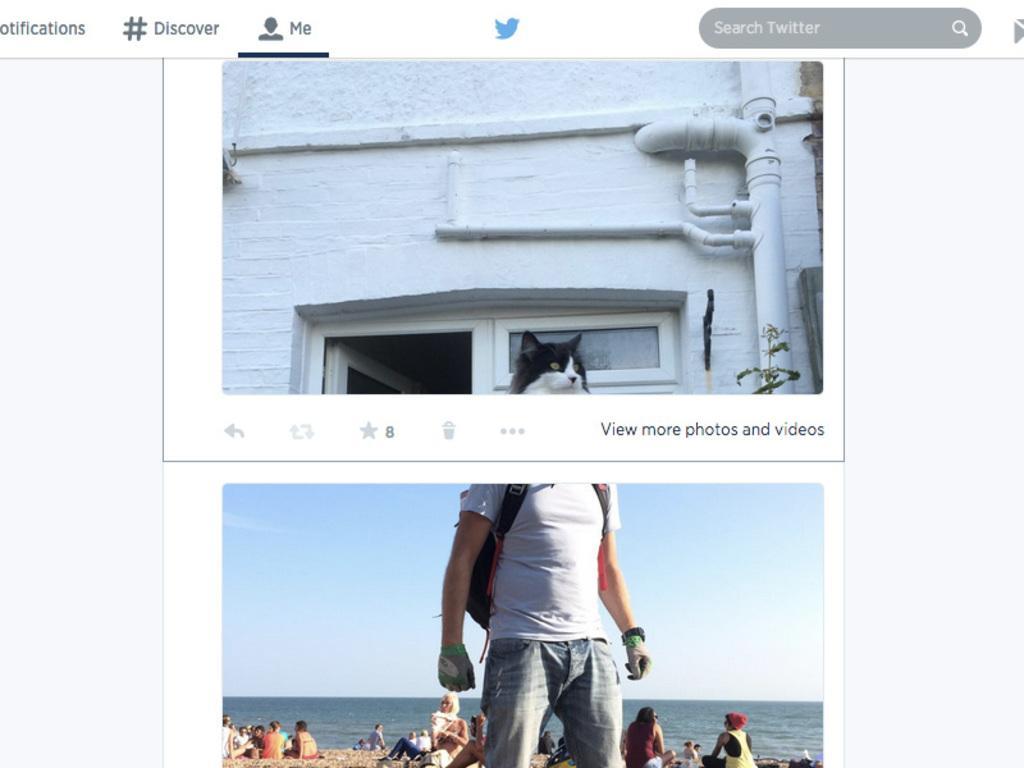How would you summarize this image in a sentence or two? In this image there is a college, there is a cat, there is a building, there are group of persons sitting on the sand, there is a sea, there is the sky, there is a man standing and wearing a bag, there is the door, there is the window, there is a bird, there is a plant, there is text, the background of the image is white in color. 